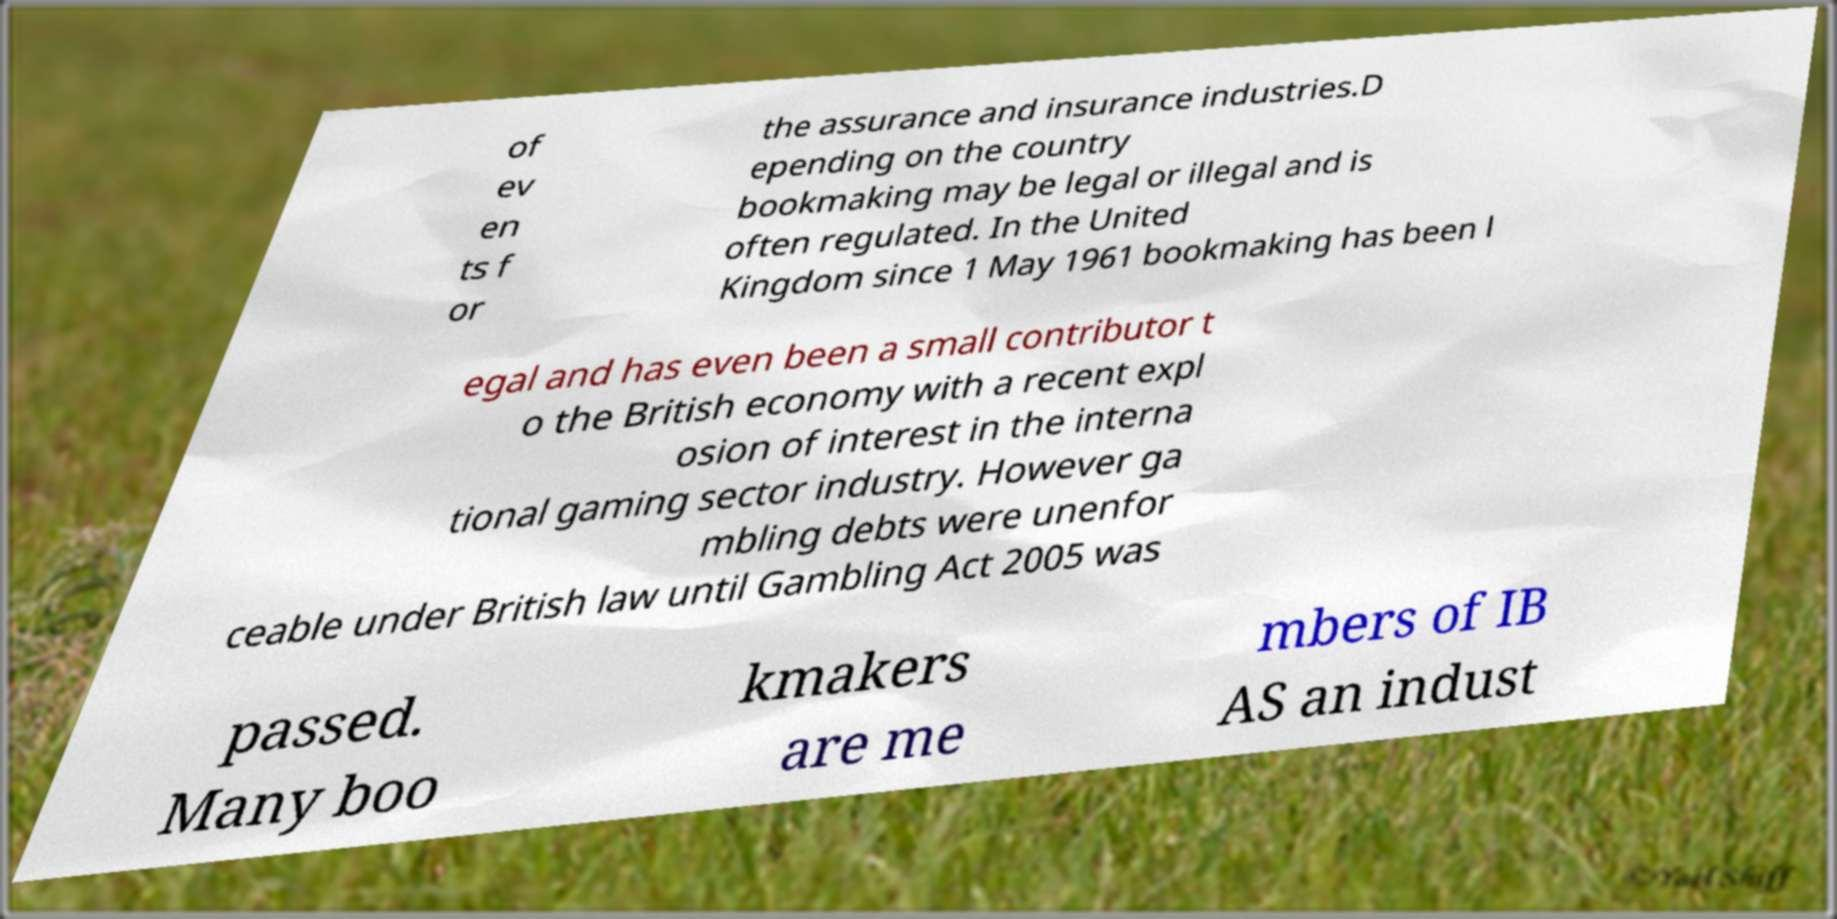I need the written content from this picture converted into text. Can you do that? of ev en ts f or the assurance and insurance industries.D epending on the country bookmaking may be legal or illegal and is often regulated. In the United Kingdom since 1 May 1961 bookmaking has been l egal and has even been a small contributor t o the British economy with a recent expl osion of interest in the interna tional gaming sector industry. However ga mbling debts were unenfor ceable under British law until Gambling Act 2005 was passed. Many boo kmakers are me mbers of IB AS an indust 